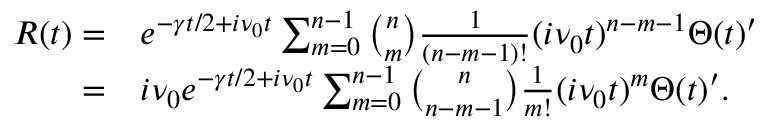<formula> <loc_0><loc_0><loc_500><loc_500>\begin{array} { r l } { R ( t ) = } & e ^ { - \gamma t / 2 + i \nu _ { 0 } t } \sum _ { m = 0 } ^ { n - 1 } \binom { n } { m } \frac { 1 } { ( n - m - 1 ) ! } ( i \nu _ { 0 } t ) ^ { n - m - 1 } \Theta ( t ) ^ { \prime } } \\ { = } & i \nu _ { 0 } e ^ { - \gamma t / 2 + i \nu _ { 0 } t } \sum _ { m = 0 } ^ { n - 1 } \binom { n } { n - m - 1 } \frac { 1 } { m ! } ( i \nu _ { 0 } t ) ^ { m } \Theta ( t ) ^ { \prime } . } \end{array}</formula> 